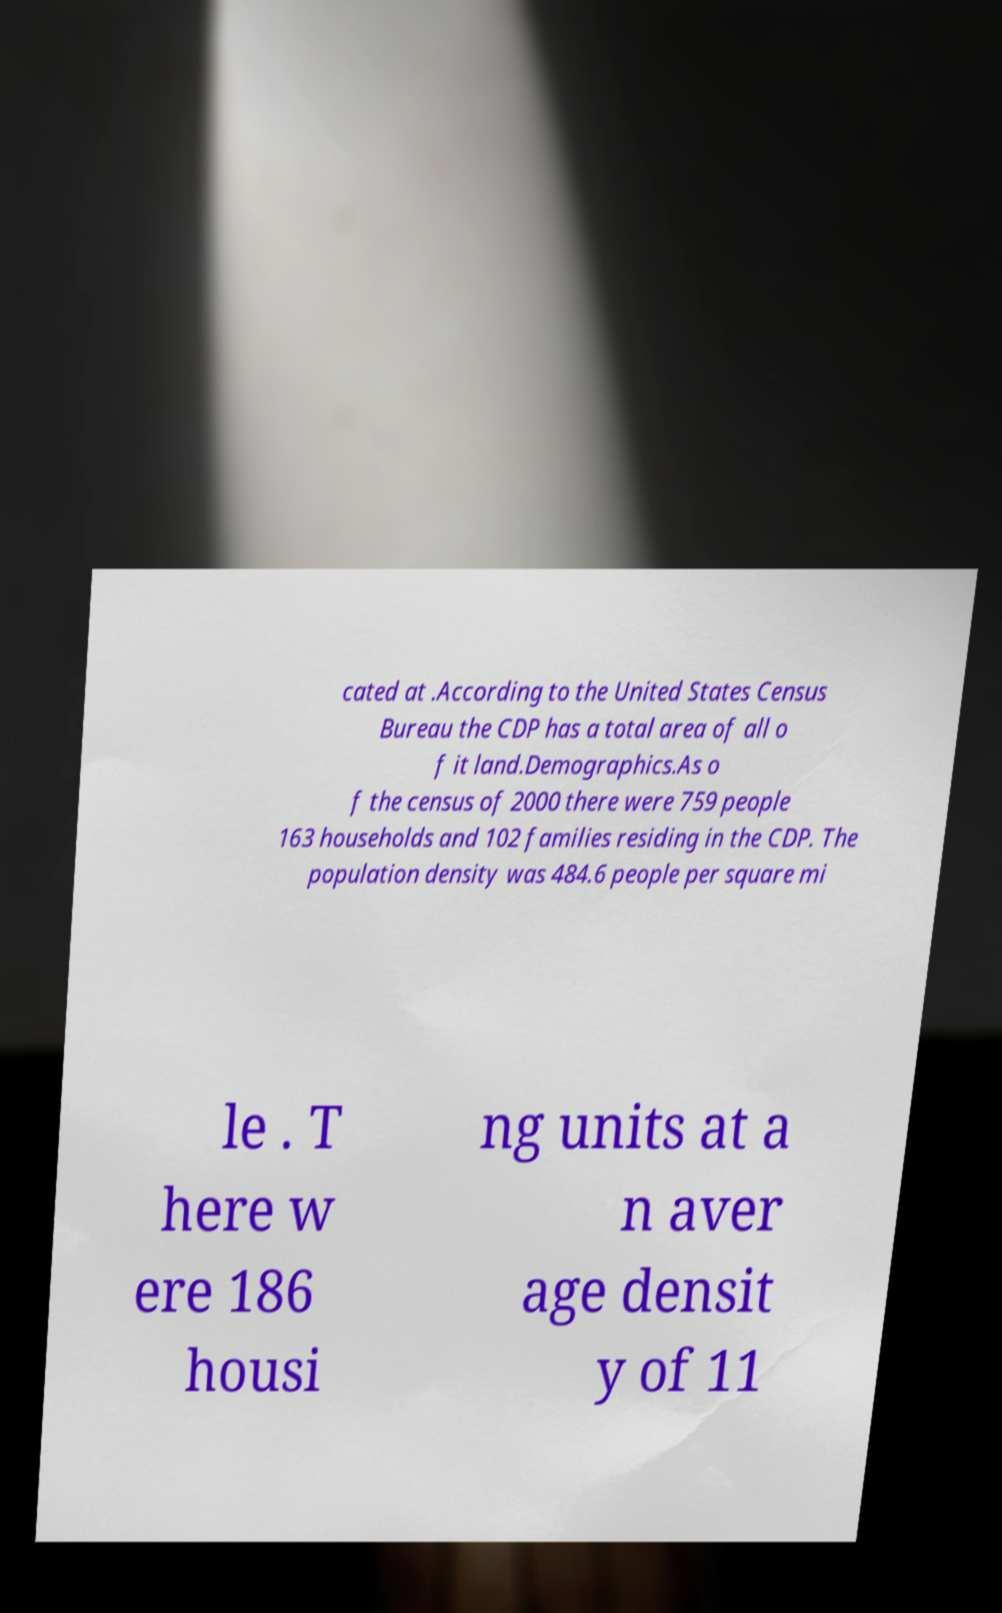Please identify and transcribe the text found in this image. cated at .According to the United States Census Bureau the CDP has a total area of all o f it land.Demographics.As o f the census of 2000 there were 759 people 163 households and 102 families residing in the CDP. The population density was 484.6 people per square mi le . T here w ere 186 housi ng units at a n aver age densit y of 11 